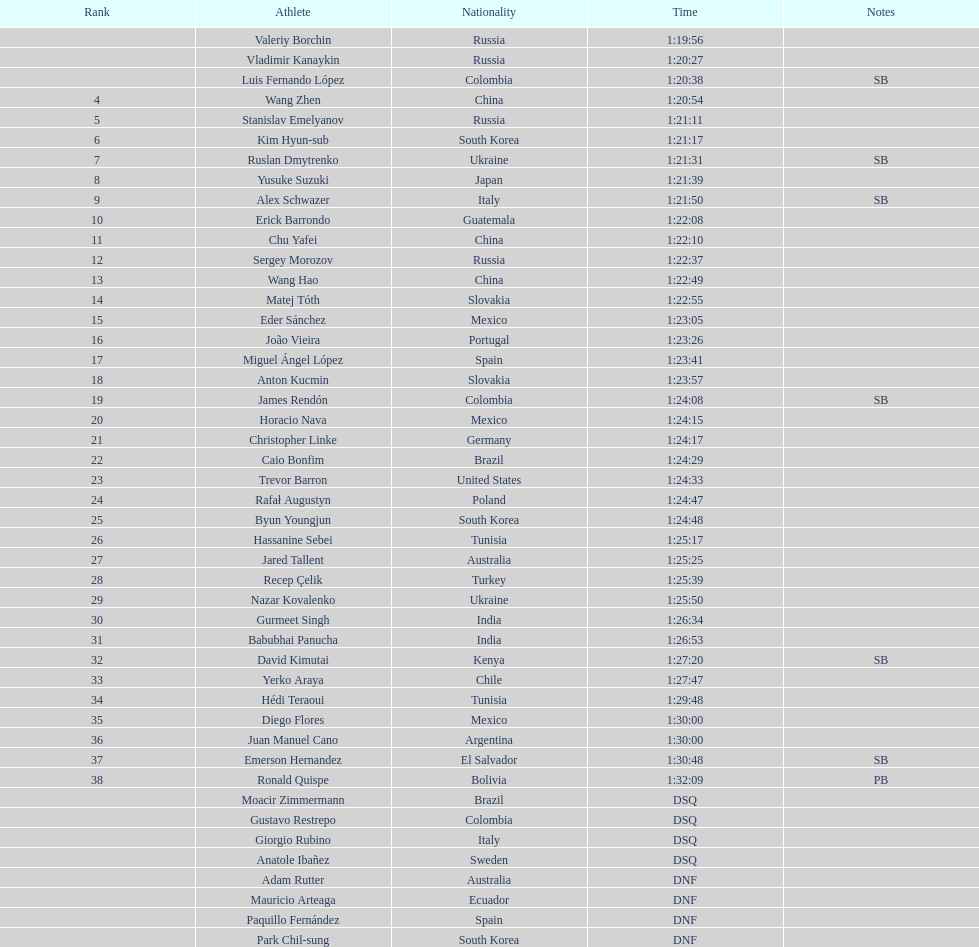How many russians secured at least a 3rd place finish in the 20km walk? 2. I'm looking to parse the entire table for insights. Could you assist me with that? {'header': ['Rank', 'Athlete', 'Nationality', 'Time', 'Notes'], 'rows': [['', 'Valeriy Borchin', 'Russia', '1:19:56', ''], ['', 'Vladimir Kanaykin', 'Russia', '1:20:27', ''], ['', 'Luis Fernando López', 'Colombia', '1:20:38', 'SB'], ['4', 'Wang Zhen', 'China', '1:20:54', ''], ['5', 'Stanislav Emelyanov', 'Russia', '1:21:11', ''], ['6', 'Kim Hyun-sub', 'South Korea', '1:21:17', ''], ['7', 'Ruslan Dmytrenko', 'Ukraine', '1:21:31', 'SB'], ['8', 'Yusuke Suzuki', 'Japan', '1:21:39', ''], ['9', 'Alex Schwazer', 'Italy', '1:21:50', 'SB'], ['10', 'Erick Barrondo', 'Guatemala', '1:22:08', ''], ['11', 'Chu Yafei', 'China', '1:22:10', ''], ['12', 'Sergey Morozov', 'Russia', '1:22:37', ''], ['13', 'Wang Hao', 'China', '1:22:49', ''], ['14', 'Matej Tóth', 'Slovakia', '1:22:55', ''], ['15', 'Eder Sánchez', 'Mexico', '1:23:05', ''], ['16', 'João Vieira', 'Portugal', '1:23:26', ''], ['17', 'Miguel Ángel López', 'Spain', '1:23:41', ''], ['18', 'Anton Kucmin', 'Slovakia', '1:23:57', ''], ['19', 'James Rendón', 'Colombia', '1:24:08', 'SB'], ['20', 'Horacio Nava', 'Mexico', '1:24:15', ''], ['21', 'Christopher Linke', 'Germany', '1:24:17', ''], ['22', 'Caio Bonfim', 'Brazil', '1:24:29', ''], ['23', 'Trevor Barron', 'United States', '1:24:33', ''], ['24', 'Rafał Augustyn', 'Poland', '1:24:47', ''], ['25', 'Byun Youngjun', 'South Korea', '1:24:48', ''], ['26', 'Hassanine Sebei', 'Tunisia', '1:25:17', ''], ['27', 'Jared Tallent', 'Australia', '1:25:25', ''], ['28', 'Recep Çelik', 'Turkey', '1:25:39', ''], ['29', 'Nazar Kovalenko', 'Ukraine', '1:25:50', ''], ['30', 'Gurmeet Singh', 'India', '1:26:34', ''], ['31', 'Babubhai Panucha', 'India', '1:26:53', ''], ['32', 'David Kimutai', 'Kenya', '1:27:20', 'SB'], ['33', 'Yerko Araya', 'Chile', '1:27:47', ''], ['34', 'Hédi Teraoui', 'Tunisia', '1:29:48', ''], ['35', 'Diego Flores', 'Mexico', '1:30:00', ''], ['36', 'Juan Manuel Cano', 'Argentina', '1:30:00', ''], ['37', 'Emerson Hernandez', 'El Salvador', '1:30:48', 'SB'], ['38', 'Ronald Quispe', 'Bolivia', '1:32:09', 'PB'], ['', 'Moacir Zimmermann', 'Brazil', 'DSQ', ''], ['', 'Gustavo Restrepo', 'Colombia', 'DSQ', ''], ['', 'Giorgio Rubino', 'Italy', 'DSQ', ''], ['', 'Anatole Ibañez', 'Sweden', 'DSQ', ''], ['', 'Adam Rutter', 'Australia', 'DNF', ''], ['', 'Mauricio Arteaga', 'Ecuador', 'DNF', ''], ['', 'Paquillo Fernández', 'Spain', 'DNF', ''], ['', 'Park Chil-sung', 'South Korea', 'DNF', '']]} 